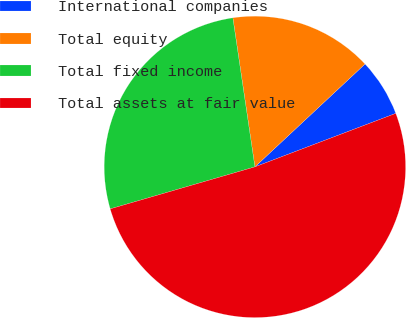<chart> <loc_0><loc_0><loc_500><loc_500><pie_chart><fcel>International companies<fcel>Total equity<fcel>Total fixed income<fcel>Total assets at fair value<nl><fcel>6.18%<fcel>15.38%<fcel>27.16%<fcel>51.28%<nl></chart> 